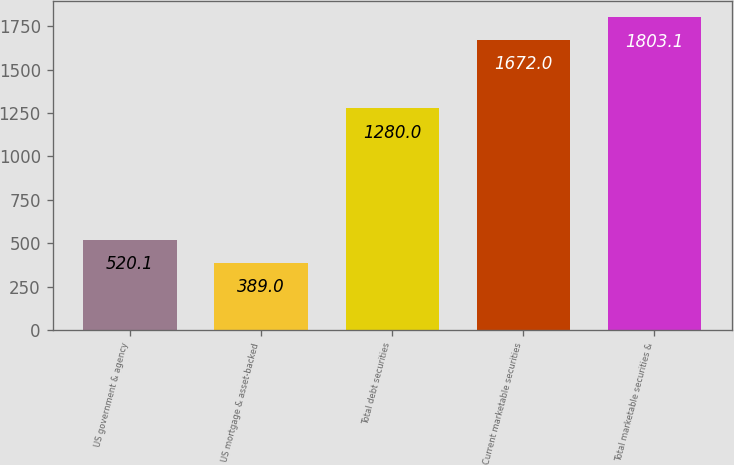Convert chart. <chart><loc_0><loc_0><loc_500><loc_500><bar_chart><fcel>US government & agency<fcel>US mortgage & asset-backed<fcel>Total debt securities<fcel>Current marketable securities<fcel>Total marketable securities &<nl><fcel>520.1<fcel>389<fcel>1280<fcel>1672<fcel>1803.1<nl></chart> 